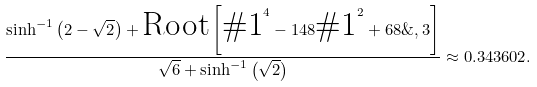<formula> <loc_0><loc_0><loc_500><loc_500>\frac { \sinh ^ { - 1 } \left ( 2 - \sqrt { 2 } \right ) + \text {Root} \left [ \text {$\#  $1} ^ { 4 } - 1 4 8 \text {$\#$1} ^ { 2 } + 6 8 \& , 3 \right ] } { \sqrt { 6 } + \sinh ^ { - 1 } \left ( \sqrt { 2 } \right ) } \approx 0 . 3 4 3 6 0 2 .</formula> 